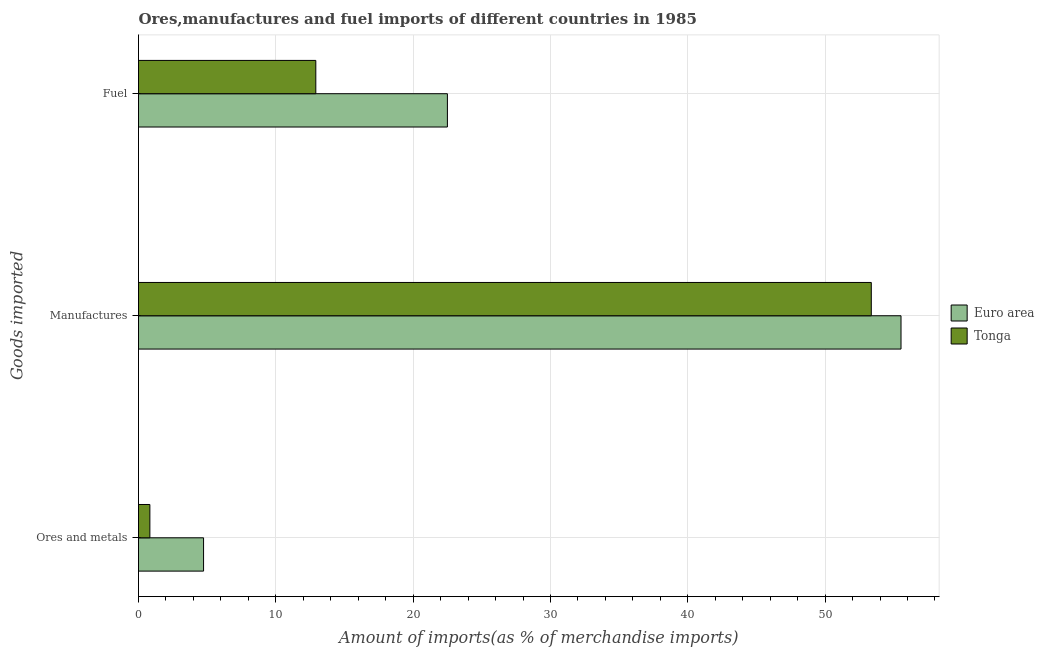How many different coloured bars are there?
Ensure brevity in your answer.  2. Are the number of bars per tick equal to the number of legend labels?
Your answer should be compact. Yes. How many bars are there on the 3rd tick from the top?
Provide a succinct answer. 2. What is the label of the 1st group of bars from the top?
Make the answer very short. Fuel. What is the percentage of manufactures imports in Euro area?
Provide a succinct answer. 55.53. Across all countries, what is the maximum percentage of ores and metals imports?
Offer a terse response. 4.74. Across all countries, what is the minimum percentage of fuel imports?
Give a very brief answer. 12.91. In which country was the percentage of fuel imports minimum?
Offer a very short reply. Tonga. What is the total percentage of manufactures imports in the graph?
Your answer should be compact. 108.89. What is the difference between the percentage of manufactures imports in Euro area and that in Tonga?
Provide a short and direct response. 2.16. What is the difference between the percentage of ores and metals imports in Tonga and the percentage of manufactures imports in Euro area?
Your answer should be compact. -54.7. What is the average percentage of manufactures imports per country?
Your response must be concise. 54.44. What is the difference between the percentage of manufactures imports and percentage of fuel imports in Euro area?
Provide a short and direct response. 33.03. What is the ratio of the percentage of fuel imports in Tonga to that in Euro area?
Your answer should be compact. 0.57. Is the percentage of manufactures imports in Euro area less than that in Tonga?
Ensure brevity in your answer.  No. Is the difference between the percentage of ores and metals imports in Tonga and Euro area greater than the difference between the percentage of fuel imports in Tonga and Euro area?
Ensure brevity in your answer.  Yes. What is the difference between the highest and the second highest percentage of fuel imports?
Provide a short and direct response. 9.58. What is the difference between the highest and the lowest percentage of ores and metals imports?
Your response must be concise. 3.91. Is the sum of the percentage of ores and metals imports in Tonga and Euro area greater than the maximum percentage of manufactures imports across all countries?
Your answer should be compact. No. What does the 1st bar from the bottom in Ores and metals represents?
Your answer should be very brief. Euro area. Is it the case that in every country, the sum of the percentage of ores and metals imports and percentage of manufactures imports is greater than the percentage of fuel imports?
Your response must be concise. Yes. Are the values on the major ticks of X-axis written in scientific E-notation?
Offer a very short reply. No. Does the graph contain any zero values?
Your answer should be very brief. No. Does the graph contain grids?
Offer a very short reply. Yes. Where does the legend appear in the graph?
Your answer should be very brief. Center right. How many legend labels are there?
Offer a terse response. 2. How are the legend labels stacked?
Offer a terse response. Vertical. What is the title of the graph?
Provide a short and direct response. Ores,manufactures and fuel imports of different countries in 1985. Does "Timor-Leste" appear as one of the legend labels in the graph?
Offer a terse response. No. What is the label or title of the X-axis?
Your answer should be very brief. Amount of imports(as % of merchandise imports). What is the label or title of the Y-axis?
Your answer should be very brief. Goods imported. What is the Amount of imports(as % of merchandise imports) in Euro area in Ores and metals?
Provide a succinct answer. 4.74. What is the Amount of imports(as % of merchandise imports) in Tonga in Ores and metals?
Your response must be concise. 0.83. What is the Amount of imports(as % of merchandise imports) of Euro area in Manufactures?
Make the answer very short. 55.53. What is the Amount of imports(as % of merchandise imports) of Tonga in Manufactures?
Keep it short and to the point. 53.36. What is the Amount of imports(as % of merchandise imports) of Euro area in Fuel?
Your answer should be very brief. 22.49. What is the Amount of imports(as % of merchandise imports) in Tonga in Fuel?
Ensure brevity in your answer.  12.91. Across all Goods imported, what is the maximum Amount of imports(as % of merchandise imports) in Euro area?
Your answer should be compact. 55.53. Across all Goods imported, what is the maximum Amount of imports(as % of merchandise imports) of Tonga?
Your answer should be compact. 53.36. Across all Goods imported, what is the minimum Amount of imports(as % of merchandise imports) of Euro area?
Give a very brief answer. 4.74. Across all Goods imported, what is the minimum Amount of imports(as % of merchandise imports) of Tonga?
Make the answer very short. 0.83. What is the total Amount of imports(as % of merchandise imports) of Euro area in the graph?
Offer a very short reply. 82.76. What is the total Amount of imports(as % of merchandise imports) of Tonga in the graph?
Your answer should be compact. 67.1. What is the difference between the Amount of imports(as % of merchandise imports) in Euro area in Ores and metals and that in Manufactures?
Provide a short and direct response. -50.79. What is the difference between the Amount of imports(as % of merchandise imports) in Tonga in Ores and metals and that in Manufactures?
Make the answer very short. -52.53. What is the difference between the Amount of imports(as % of merchandise imports) of Euro area in Ores and metals and that in Fuel?
Offer a very short reply. -17.76. What is the difference between the Amount of imports(as % of merchandise imports) of Tonga in Ores and metals and that in Fuel?
Your answer should be compact. -12.08. What is the difference between the Amount of imports(as % of merchandise imports) in Euro area in Manufactures and that in Fuel?
Offer a very short reply. 33.03. What is the difference between the Amount of imports(as % of merchandise imports) in Tonga in Manufactures and that in Fuel?
Keep it short and to the point. 40.45. What is the difference between the Amount of imports(as % of merchandise imports) in Euro area in Ores and metals and the Amount of imports(as % of merchandise imports) in Tonga in Manufactures?
Offer a terse response. -48.62. What is the difference between the Amount of imports(as % of merchandise imports) of Euro area in Ores and metals and the Amount of imports(as % of merchandise imports) of Tonga in Fuel?
Your answer should be very brief. -8.17. What is the difference between the Amount of imports(as % of merchandise imports) in Euro area in Manufactures and the Amount of imports(as % of merchandise imports) in Tonga in Fuel?
Keep it short and to the point. 42.62. What is the average Amount of imports(as % of merchandise imports) in Euro area per Goods imported?
Your answer should be compact. 27.59. What is the average Amount of imports(as % of merchandise imports) of Tonga per Goods imported?
Provide a succinct answer. 22.37. What is the difference between the Amount of imports(as % of merchandise imports) in Euro area and Amount of imports(as % of merchandise imports) in Tonga in Ores and metals?
Provide a succinct answer. 3.91. What is the difference between the Amount of imports(as % of merchandise imports) in Euro area and Amount of imports(as % of merchandise imports) in Tonga in Manufactures?
Your answer should be very brief. 2.16. What is the difference between the Amount of imports(as % of merchandise imports) of Euro area and Amount of imports(as % of merchandise imports) of Tonga in Fuel?
Your answer should be compact. 9.58. What is the ratio of the Amount of imports(as % of merchandise imports) in Euro area in Ores and metals to that in Manufactures?
Make the answer very short. 0.09. What is the ratio of the Amount of imports(as % of merchandise imports) of Tonga in Ores and metals to that in Manufactures?
Provide a short and direct response. 0.02. What is the ratio of the Amount of imports(as % of merchandise imports) of Euro area in Ores and metals to that in Fuel?
Make the answer very short. 0.21. What is the ratio of the Amount of imports(as % of merchandise imports) of Tonga in Ores and metals to that in Fuel?
Give a very brief answer. 0.06. What is the ratio of the Amount of imports(as % of merchandise imports) in Euro area in Manufactures to that in Fuel?
Your answer should be very brief. 2.47. What is the ratio of the Amount of imports(as % of merchandise imports) in Tonga in Manufactures to that in Fuel?
Keep it short and to the point. 4.13. What is the difference between the highest and the second highest Amount of imports(as % of merchandise imports) in Euro area?
Keep it short and to the point. 33.03. What is the difference between the highest and the second highest Amount of imports(as % of merchandise imports) in Tonga?
Provide a short and direct response. 40.45. What is the difference between the highest and the lowest Amount of imports(as % of merchandise imports) in Euro area?
Give a very brief answer. 50.79. What is the difference between the highest and the lowest Amount of imports(as % of merchandise imports) of Tonga?
Provide a short and direct response. 52.53. 